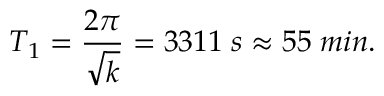<formula> <loc_0><loc_0><loc_500><loc_500>T _ { 1 } = { \frac { 2 \pi } { \sqrt { k } } } = 3 3 1 1 \, s \approx 5 5 \, \min .</formula> 